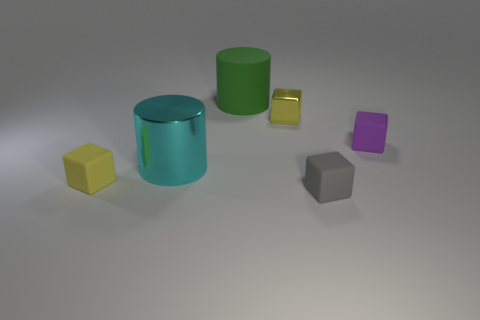Subtract all small yellow metallic cubes. How many cubes are left? 3 Add 1 green objects. How many objects exist? 7 Subtract all purple blocks. How many blocks are left? 3 Subtract all cubes. How many objects are left? 2 Subtract all cyan balls. How many green cubes are left? 0 Subtract all yellow rubber objects. Subtract all green cylinders. How many objects are left? 4 Add 5 small blocks. How many small blocks are left? 9 Add 4 gray things. How many gray things exist? 5 Subtract 0 purple cylinders. How many objects are left? 6 Subtract 1 blocks. How many blocks are left? 3 